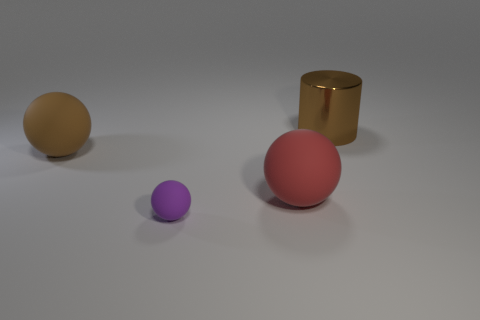Add 1 cylinders. How many objects exist? 5 Subtract all large red matte balls. How many balls are left? 2 Subtract all purple spheres. How many spheres are left? 2 Subtract 2 spheres. How many spheres are left? 1 Add 4 large cyan matte cylinders. How many large cyan matte cylinders exist? 4 Subtract 0 cyan spheres. How many objects are left? 4 Subtract all cylinders. How many objects are left? 3 Subtract all blue balls. Subtract all green cubes. How many balls are left? 3 Subtract all brown spheres. How many green cylinders are left? 0 Subtract all blue matte cylinders. Subtract all large brown shiny cylinders. How many objects are left? 3 